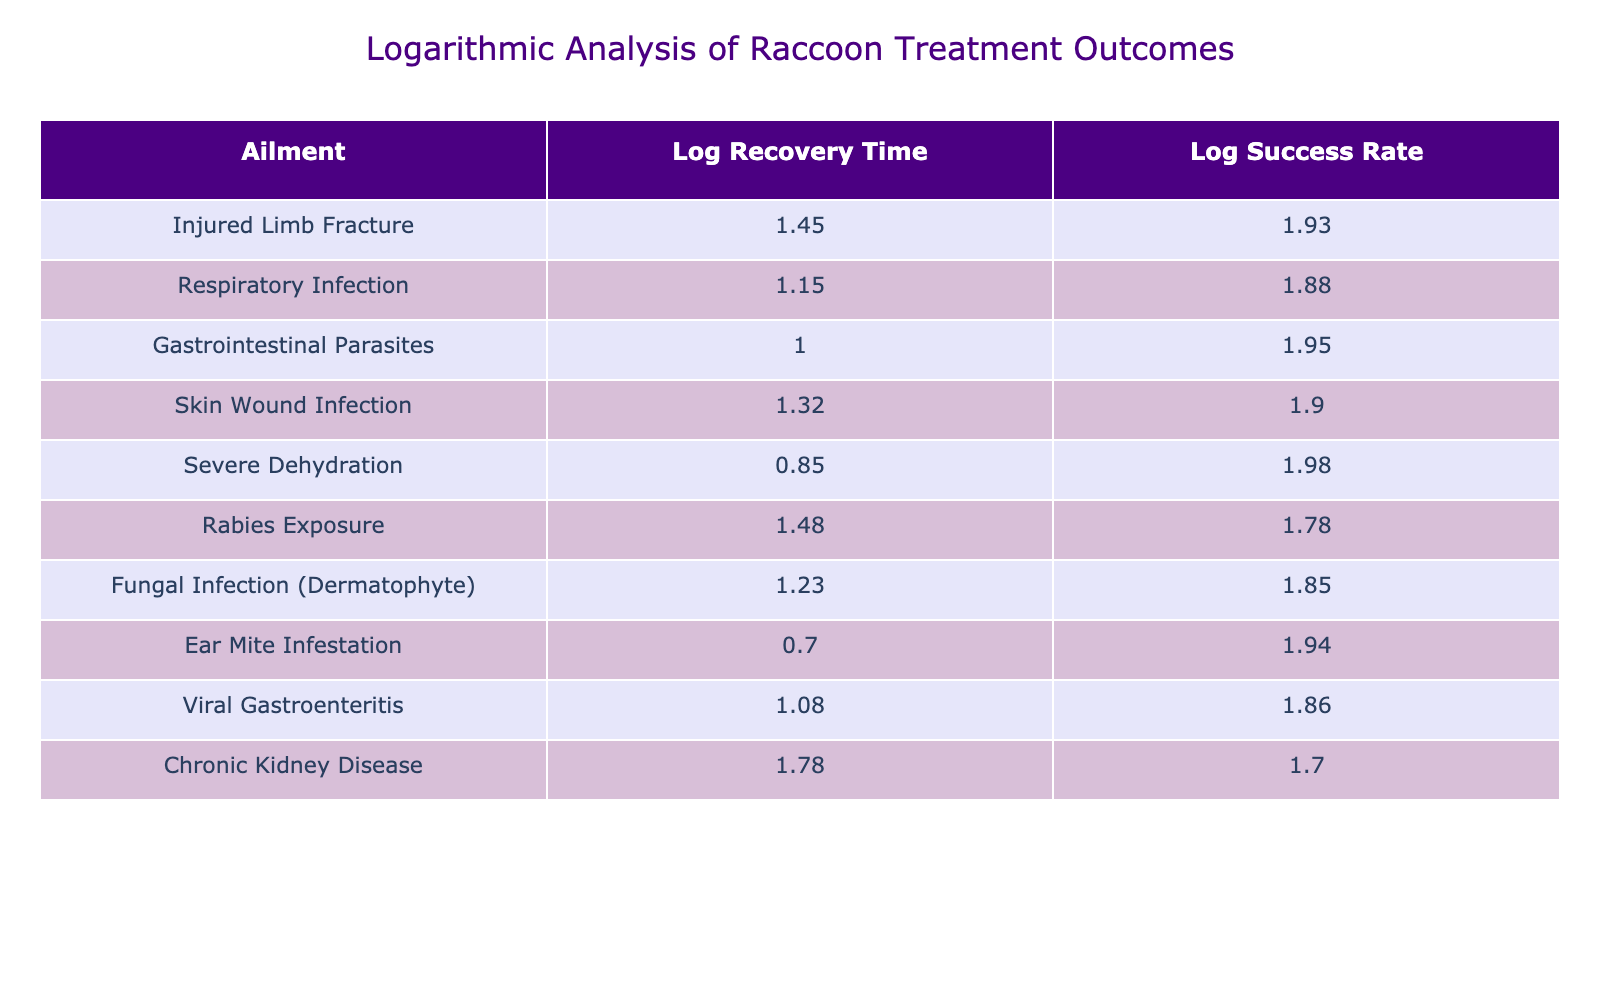What is the logarithmic value of the treatment success rate for gastrointestinal parasites? From the table, the treatment success rate for gastrointestinal parasites is 90%. The logarithmic value is calculated as log10(90), which equals approximately 1.95 when rounded to two decimal places.
Answer: 1.95 What is the average recovery time for raccoons with skin wound infection? The table specifies that the average recovery time for skin wound infection is 21 days. There is no additional calculation needed to answer this question.
Answer: 21 days Is the treatment success rate for rabies exposure higher than that for respiratory infection? Looking at the treatment success rates, rabies exposure has a success rate of 60% while respiratory infection has a rate of 75%. Since 60% is less than 75%, the fact is false.
Answer: No What is the difference between the logarithmic recovery time for injured limb fracture and that for severe dehydration? The logarithmic recovery time for injured limb fracture is log10(28) which is approximately 1.45, and for severe dehydration, it is log10(7), approximately 0.85. The difference is calculated as 1.45 - 0.85 = 0.60.
Answer: 0.60 Which ailment has the shortest average recovery time and what is that time? From the table, ear mite infestation has the shortest average recovery time at 5 days. No further calculations are needed to obtain this information.
Answer: 5 days How many ailments have a treatment success rate of 75% or higher? The treatment success rates of the ailments in the table are as follows: Injured Limb Fracture (85%), Respiratory Infection (75%), Gastrointestinal Parasites (90%), Skin Wound Infection (80%), Severe Dehydration (95%), and Ear Mite Infestation (88%). This totals to 6 ailments with a success rate of 75% or higher.
Answer: 6 What is the logarithmic value of the average recovery time for chronic kidney disease? The average recovery time for chronic kidney disease is 60 days. The logarithmic value is calculated as log10(60), which is approximately 1.78 when rounded to two decimal places.
Answer: 1.78 Is it true that the average recovery time for gastrointestinal parasites is lower than that for skin wound infection? The average recovery time for gastrointestinal parasites is 10 days, while for skin wound infection it is 21 days. Since 10 is less than 21, the fact is true.
Answer: Yes Calculate the average of the logarithmic treatment success rates for all ailments listed. The logarithmic treatment success rates for the ailments are as follows: log10(85) ≈ 1.93, log10(75) ≈ 1.88, log10(90) ≈ 1.95, log10(80) ≈ 1.90, log10(95) ≈ 1.98, log10(60) ≈ 1.78, log10(70) ≈ 1.84, log10(88) ≈ 1.95, log10(72) ≈ 1.83, log10(50) ≈ 1.70. The sum is approximately 18.46, and dividing by 10 gives an average of 1.85.
Answer: 1.85 